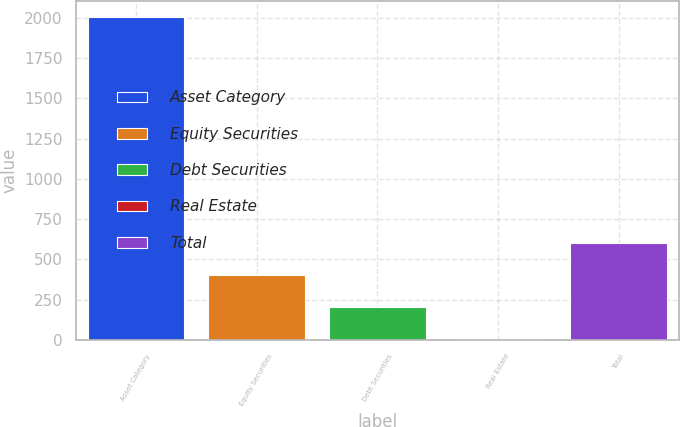Convert chart to OTSL. <chart><loc_0><loc_0><loc_500><loc_500><bar_chart><fcel>Asset Category<fcel>Equity Securities<fcel>Debt Securities<fcel>Real Estate<fcel>Total<nl><fcel>2003<fcel>403.8<fcel>203.9<fcel>4<fcel>603.7<nl></chart> 